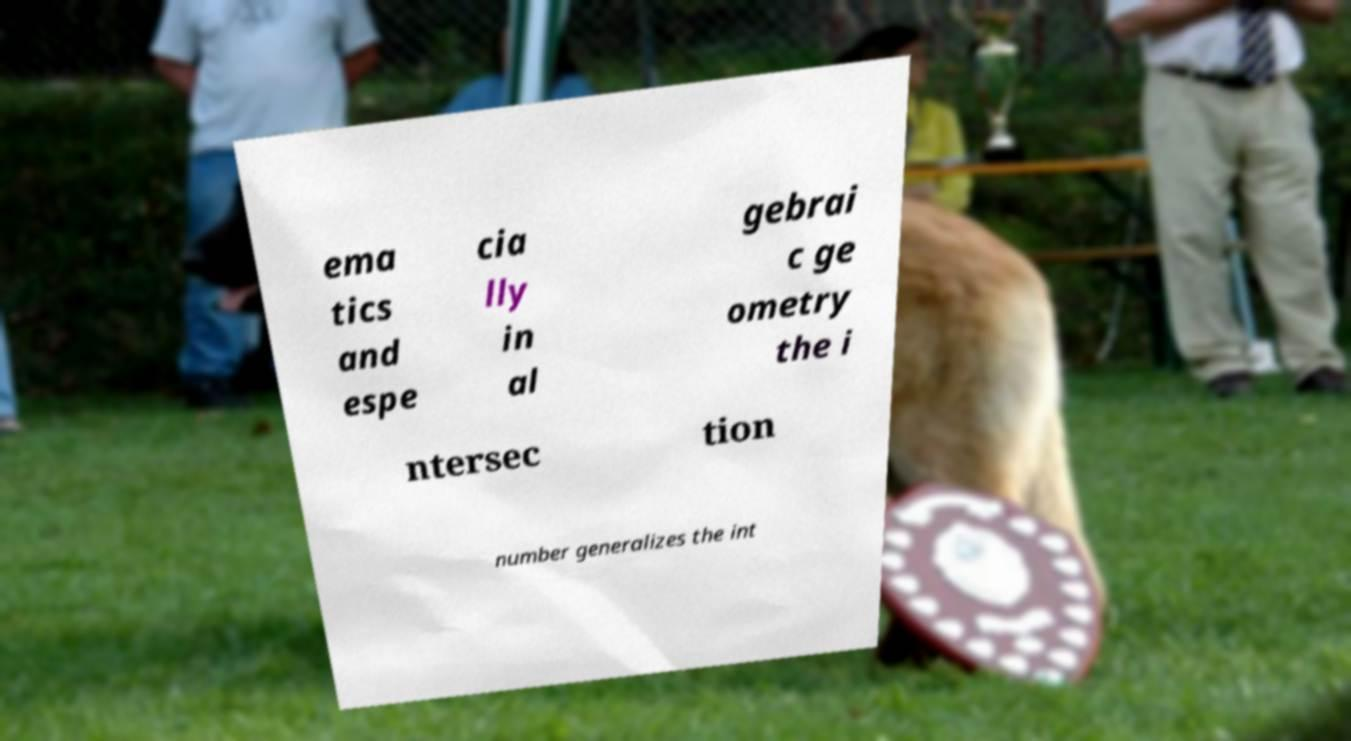Could you assist in decoding the text presented in this image and type it out clearly? ema tics and espe cia lly in al gebrai c ge ometry the i ntersec tion number generalizes the int 